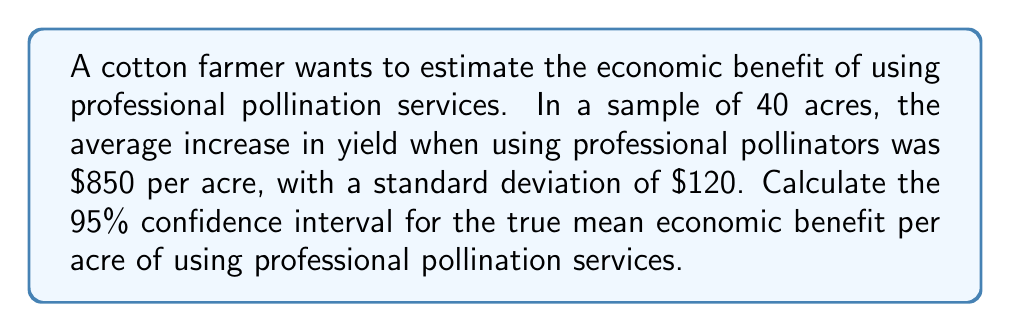Provide a solution to this math problem. To calculate the confidence interval, we'll follow these steps:

1) First, we need to identify the key information:
   - Sample size (n) = 40
   - Sample mean ($\bar{x}$) = $850
   - Sample standard deviation (s) = $120
   - Confidence level = 95%

2) For a 95% confidence interval, we use a z-score of 1.96 (assuming a normal distribution).

3) The formula for the confidence interval is:

   $$\bar{x} \pm z \cdot \frac{s}{\sqrt{n}}$$

4) Let's calculate the standard error:
   $$\frac{s}{\sqrt{n}} = \frac{120}{\sqrt{40}} = \frac{120}{6.32} = 18.99$$

5) Now, let's calculate the margin of error:
   $$1.96 \cdot 18.99 = 37.22$$

6) Finally, we can calculate the confidence interval:
   Lower bound: $850 - 37.22 = 812.78$
   Upper bound: $850 + 37.22 = 887.22$

Therefore, we are 95% confident that the true mean economic benefit per acre of using professional pollination services is between $812.78 and $887.22.
Answer: ($812.78, $887.22) 